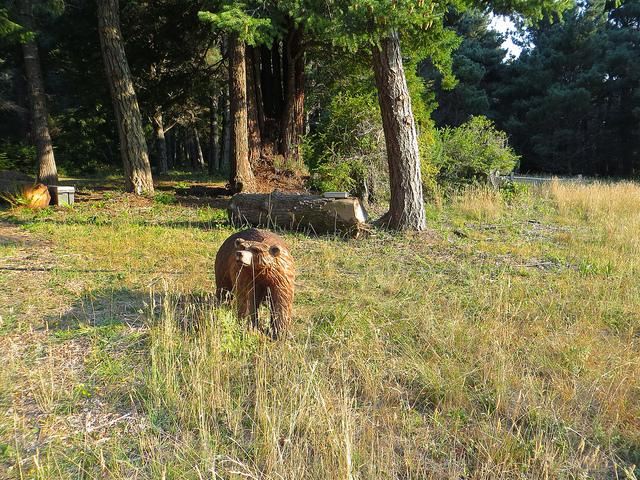What is in the green container in the background?
Concise answer only. Food. Is the bear shown real?
Concise answer only. No. Are we dead yet?
Be succinct. No. 